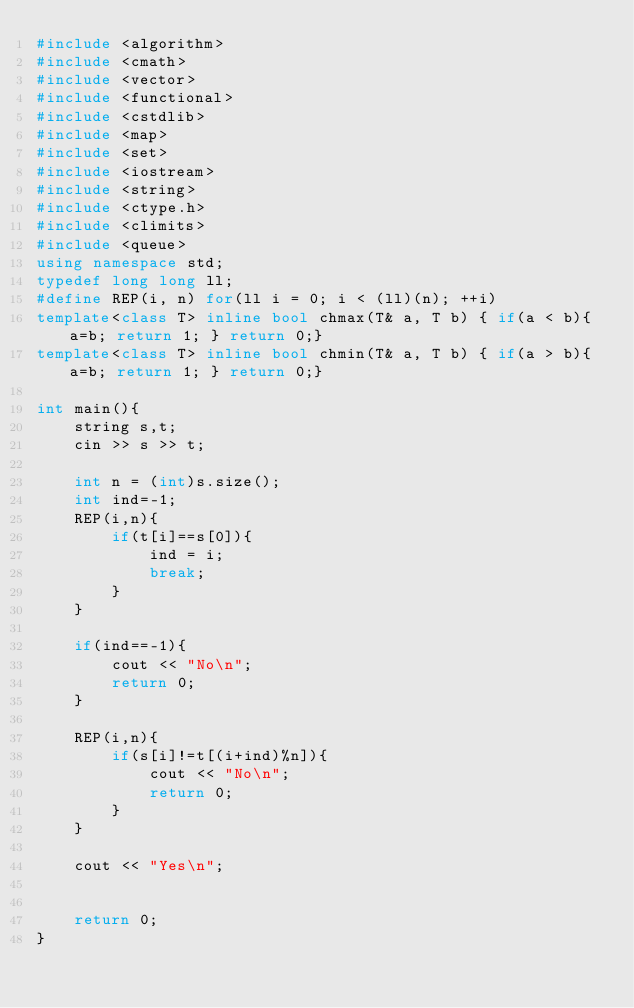Convert code to text. <code><loc_0><loc_0><loc_500><loc_500><_C++_>#include <algorithm>
#include <cmath>
#include <vector>
#include <functional>
#include <cstdlib>
#include <map>
#include <set>
#include <iostream>
#include <string>
#include <ctype.h>
#include <climits>
#include <queue>
using namespace std;
typedef long long ll;
#define REP(i, n) for(ll i = 0; i < (ll)(n); ++i)
template<class T> inline bool chmax(T& a, T b) { if(a < b){ a=b; return 1; } return 0;}
template<class T> inline bool chmin(T& a, T b) { if(a > b){ a=b; return 1; } return 0;}

int main(){
	string s,t;
	cin >> s >> t;
	
	int n = (int)s.size();
	int ind=-1;
	REP(i,n){
		if(t[i]==s[0]){
			ind = i;
			break;
		}
	}
	
	if(ind==-1){
		cout << "No\n";
		return 0; 
	}
	
	REP(i,n){
		if(s[i]!=t[(i+ind)%n]){
			cout << "No\n";
			return 0;
		}
	}
	
	cout << "Yes\n";

	
	return 0;
}</code> 